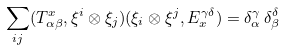Convert formula to latex. <formula><loc_0><loc_0><loc_500><loc_500>\sum _ { i j } ( T ^ { x } _ { \alpha \beta } , \xi ^ { i } \otimes \xi _ { j } ) ( \xi _ { i } \otimes \xi ^ { j } , E _ { x } ^ { \gamma \delta } ) = \delta _ { \alpha } ^ { \gamma } \, \delta _ { \beta } ^ { \delta }</formula> 